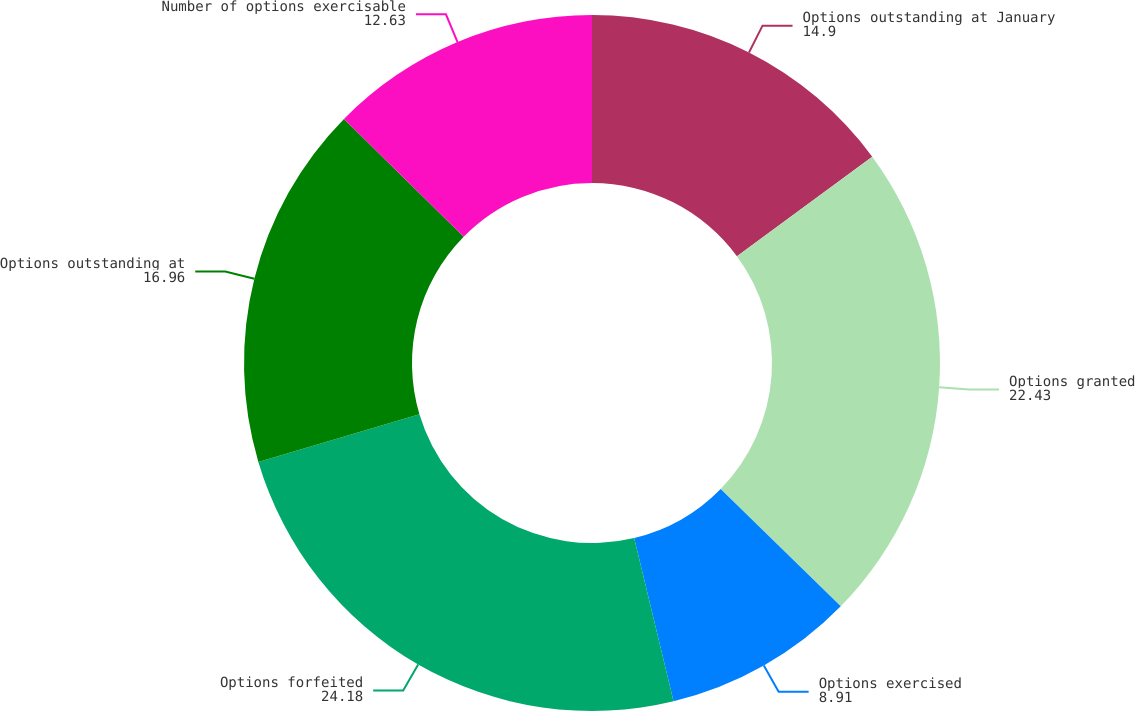Convert chart. <chart><loc_0><loc_0><loc_500><loc_500><pie_chart><fcel>Options outstanding at January<fcel>Options granted<fcel>Options exercised<fcel>Options forfeited<fcel>Options outstanding at<fcel>Number of options exercisable<nl><fcel>14.9%<fcel>22.43%<fcel>8.91%<fcel>24.18%<fcel>16.96%<fcel>12.63%<nl></chart> 